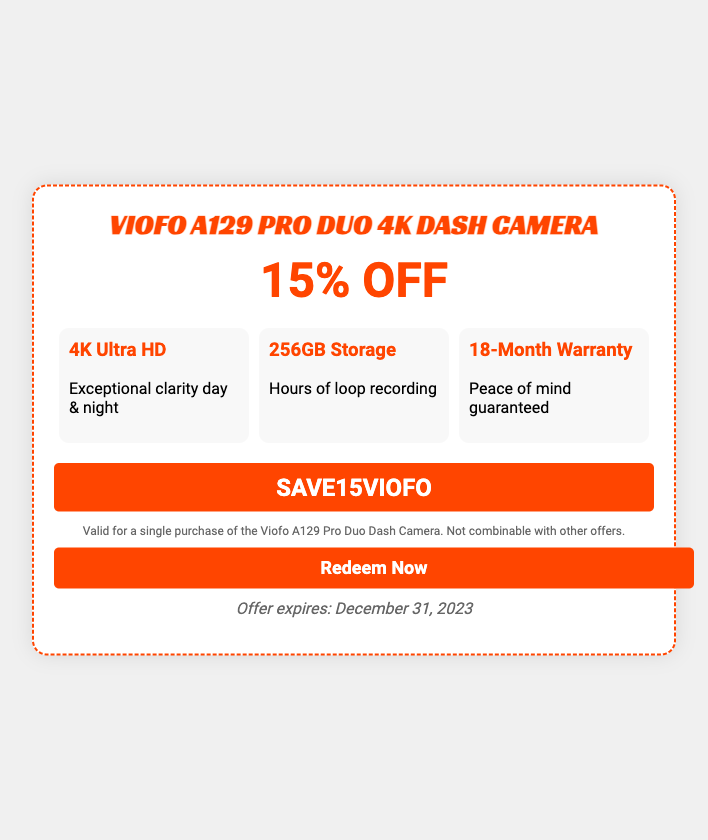What is the product featured in the voucher? The document prominently displays the Viofo A129 Pro Duo 4K Dash Camera as the featured product.
Answer: Viofo A129 Pro Duo 4K Dash Camera What is the discount percentage offered? The voucher states that the customer can save 15% off the regular price of the item.
Answer: 15% OFF How long is the warranty for the dash camera? The document mentions that the dash camera comes with an 18-month warranty for customer assurance.
Answer: 18-Month Warranty What is the storage capacity of the dash camera? According to the features listed, the dash camera has a storage capacity of 256GB.
Answer: 256GB Storage When does the offer expire? The expiration date of the offer is explicitly mentioned in the document as December 31, 2023.
Answer: December 31, 2023 What is the promotional code for the voucher? The document provides a specific code, "SAVE15VIOFO," for redeeming the offer.
Answer: SAVE15VIOFO Is the voucher combinable with other offers? The conditions section clearly states that the voucher cannot be combined with other offers.
Answer: Not combinable What type of video resolution does the camera provide? The document indicates the camera provides 4K Ultra HD resolution, highlighting its clarity.
Answer: 4K Ultra HD What should a customer do to redeem the offer? The voucher includes a clear call to action for the customer to click a button labeled "Redeem Now."
Answer: Redeem Now 